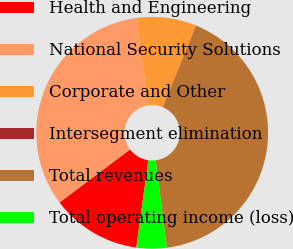Convert chart to OTSL. <chart><loc_0><loc_0><loc_500><loc_500><pie_chart><fcel>Health and Engineering<fcel>National Security Solutions<fcel>Corporate and Other<fcel>Intersegment elimination<fcel>Total revenues<fcel>Total operating income (loss)<nl><fcel>12.55%<fcel>33.06%<fcel>8.38%<fcel>0.03%<fcel>41.78%<fcel>4.2%<nl></chart> 